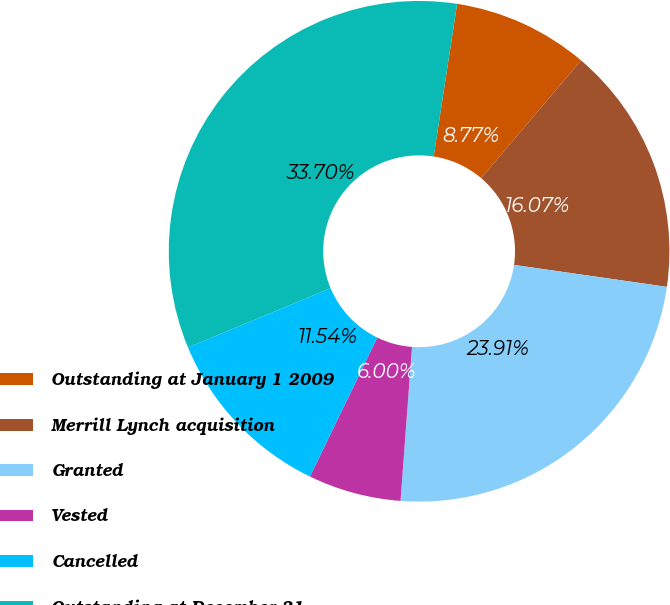Convert chart to OTSL. <chart><loc_0><loc_0><loc_500><loc_500><pie_chart><fcel>Outstanding at January 1 2009<fcel>Merrill Lynch acquisition<fcel>Granted<fcel>Vested<fcel>Cancelled<fcel>Outstanding at December 31<nl><fcel>8.77%<fcel>16.07%<fcel>23.91%<fcel>6.0%<fcel>11.54%<fcel>33.7%<nl></chart> 